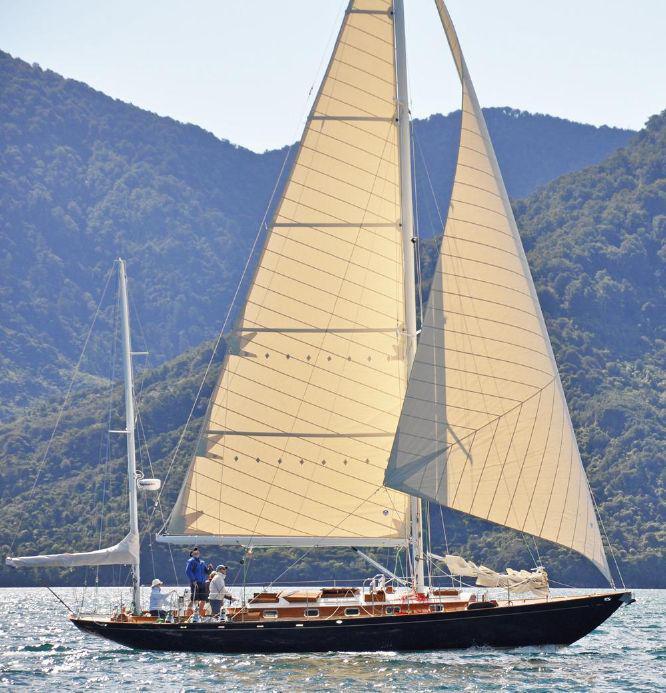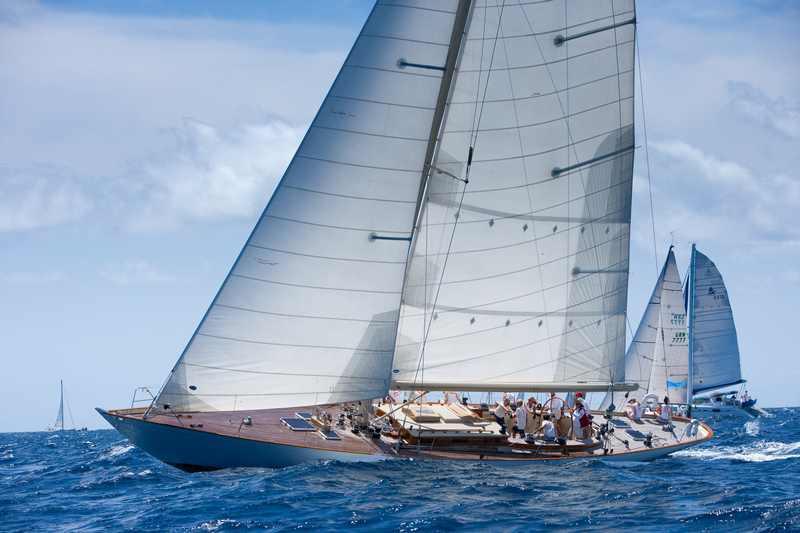The first image is the image on the left, the second image is the image on the right. Examine the images to the left and right. Is the description "There is land in the background of the image on the right." accurate? Answer yes or no. No. 